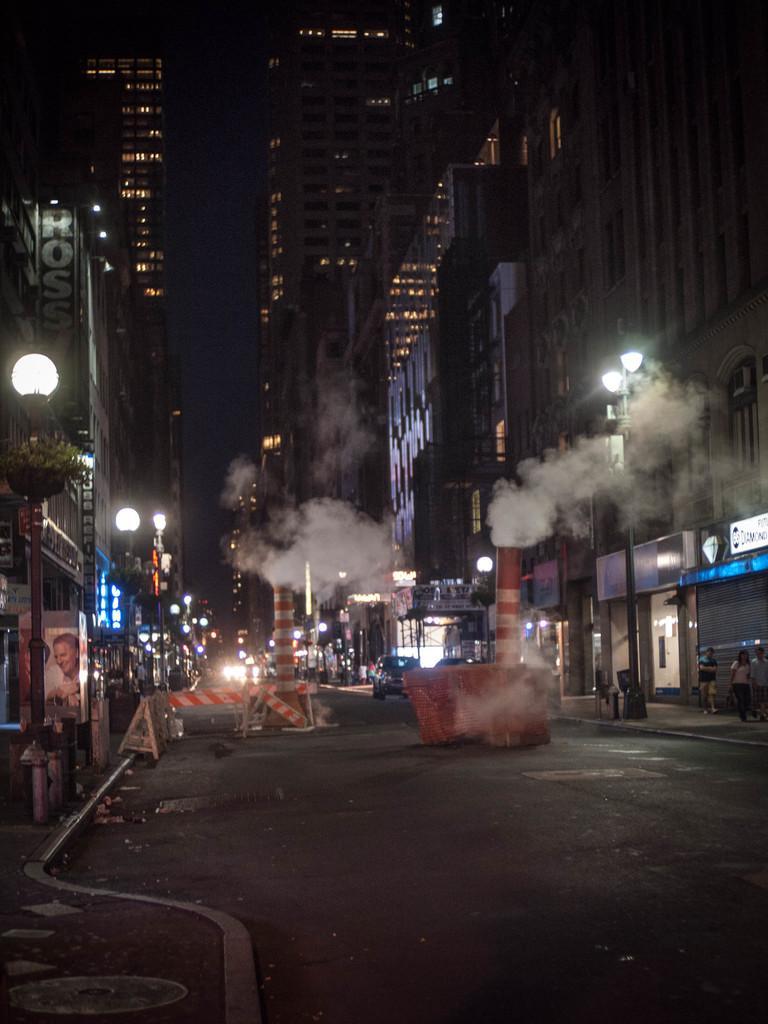Could you give a brief overview of what you see in this image? In this image at the bottom there is the road and smoke is coming from these two things. On the left side there are street lamps, there are buildings on either side of this road, at the top it is the sky. 